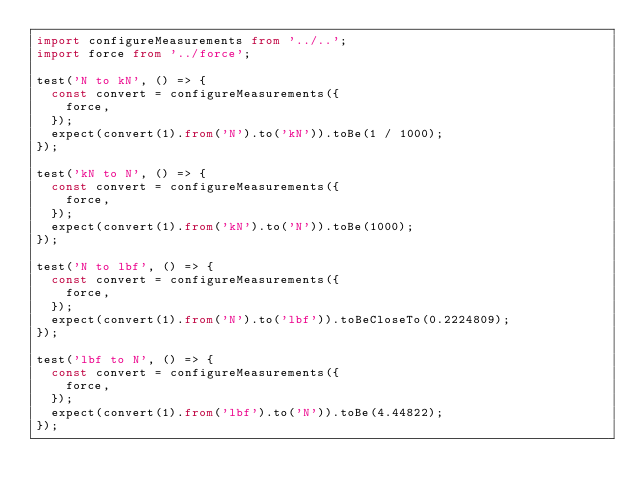Convert code to text. <code><loc_0><loc_0><loc_500><loc_500><_TypeScript_>import configureMeasurements from '../..';
import force from '../force';

test('N to kN', () => {
  const convert = configureMeasurements({
    force,
  });
  expect(convert(1).from('N').to('kN')).toBe(1 / 1000);
});

test('kN to N', () => {
  const convert = configureMeasurements({
    force,
  });
  expect(convert(1).from('kN').to('N')).toBe(1000);
});

test('N to lbf', () => {
  const convert = configureMeasurements({
    force,
  });
  expect(convert(1).from('N').to('lbf')).toBeCloseTo(0.2224809);
});

test('lbf to N', () => {
  const convert = configureMeasurements({
    force,
  });
  expect(convert(1).from('lbf').to('N')).toBe(4.44822);
});
</code> 